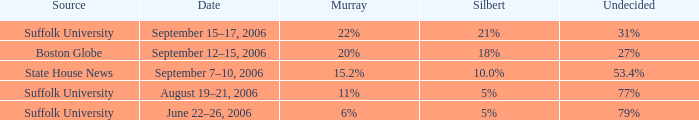What is the date of the poll with Silbert at 18%? September 12–15, 2006. 